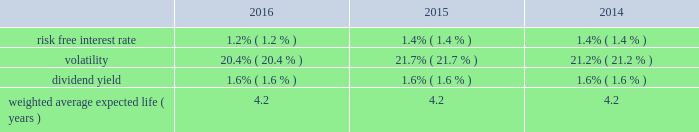Fidelity national information services , inc .
And subsidiaries notes to consolidated financial statements - ( continued ) ( a ) intrinsic value is based on a closing stock price as of december 31 , 2016 of $ 75.64 .
The weighted average fair value of options granted during the years ended december 31 , 2016 , 2015 and 2014 was estimated to be $ 9.35 , $ 10.67 and $ 9.15 , respectively , using the black-scholes option pricing model with the assumptions below: .
The company estimates future forfeitures at the time of grant and revises those estimates in subsequent periods if actual forfeitures differ from those estimates .
The company bases the risk-free interest rate that is used in the stock option valuation model on u.s .
N treasury securities issued with maturities similar to the expected term of the options .
The expected stock volatility factor is determined using historical daily price changes of the company's common stock over the most recent period commensurate with the expected term of the option and the impact of any expected trends .
The dividend yield assumption is based on the current dividend yield at the grant tt date or management's forecasted expectations .
The expected life assumption is determined by calculating the average term from the tt company's historical stock option activity and considering the impact of expected future trends .
The company granted a total of 1 million restricted stock shares at prices ranging from $ 56.44 to $ 79.41 on various dates in 2016 .
The company granted a total of 1 million restricted stock shares at prices ranging from $ 61.33 to $ 69.33 on various dates in 20t 15 .
The company granted a total of 1 million restricted stock shares at prices ranging from $ 52.85 to $ 64.04 on various dates in 2014 .
These shares were granted at the closing market price on the date of grant and vest annually over three years .
As of december 31 , 2016 and 2015 , we have approximately 3 million and 4 million unvested restricted shares remaining .
The december 31 , 2016 balance includes those rsu's converted in connection with the sungard acquisition as noted above .
The company has provided for total stock compensation expense of $ 137 million , $ 98 million and $ 56 million for the years ended december 31 , 2016 , 2015 and 2014 , respectively , which is included in selling , general , and administrative expense in the consolidated statements of earnings , unless the expense is attributable to a discontinued operation .
Of the total stock compensation expense , $ 2 million for 2014 relates to liability based awards that will not be credited to additional paid in capital until issued .
Total d compensation expense for 2016 and 2015 did not include amounts relating to liability based awards .
As of december 31 , 2016 and 2015 , the total unrecognized compensation cost related to non-vested stock awards is $ 141 million and $ 206 million , respectively , which is expected to be recognized in pre-tax income over a weighted average period of 1.4 years and 1.6 years , respectively .
German pension plans our german operations have unfunded , defined benefit plan obligations .
These obligations relate to benefits to be paid to germanaa employees upon retirement .
The accumulated benefit obligation as of december 31 , 2016 and 2015 , was $ 49 million and $ 48 million , respectively , and the projected benefit obligation was $ 50 million and $ 49 million , respectively .
The plan remains unfunded as of december 31 , 2016 .
( 15 ) divestitures and discontinued operations on december 7 , 2016 , the company entered into a definitive agreement to sell the sungard public sector and education ( "ps&e" ) businesses for $ 850 million .
The transaction included all ps&e solutions , which provide a comprehensive set of technology solutions to address public safety and public administration needs of government entities as well asn the needs of k-12 school districts .
The divestiture is consistent with our strategy to serve the financial services markets .
We received cash proceeds , net of taxes and transaction-related expenses of approximately $ 500 million .
Net cash proceeds are expected to be used to reduce outstanding debt ( see note 10 ) .
The ps&e businesses are included in the corporate and other segment .
The transaction closed on february 1 , 2017 , resulting in an expected pre-tax gain ranging from $ 85 million to $ 90 million that will .
What was the difference in millions of the accumulated benefit obligation as of december 31 , 2015 versus the projected benefit obligation? 
Computations: (48 - 49)
Answer: -1.0. 